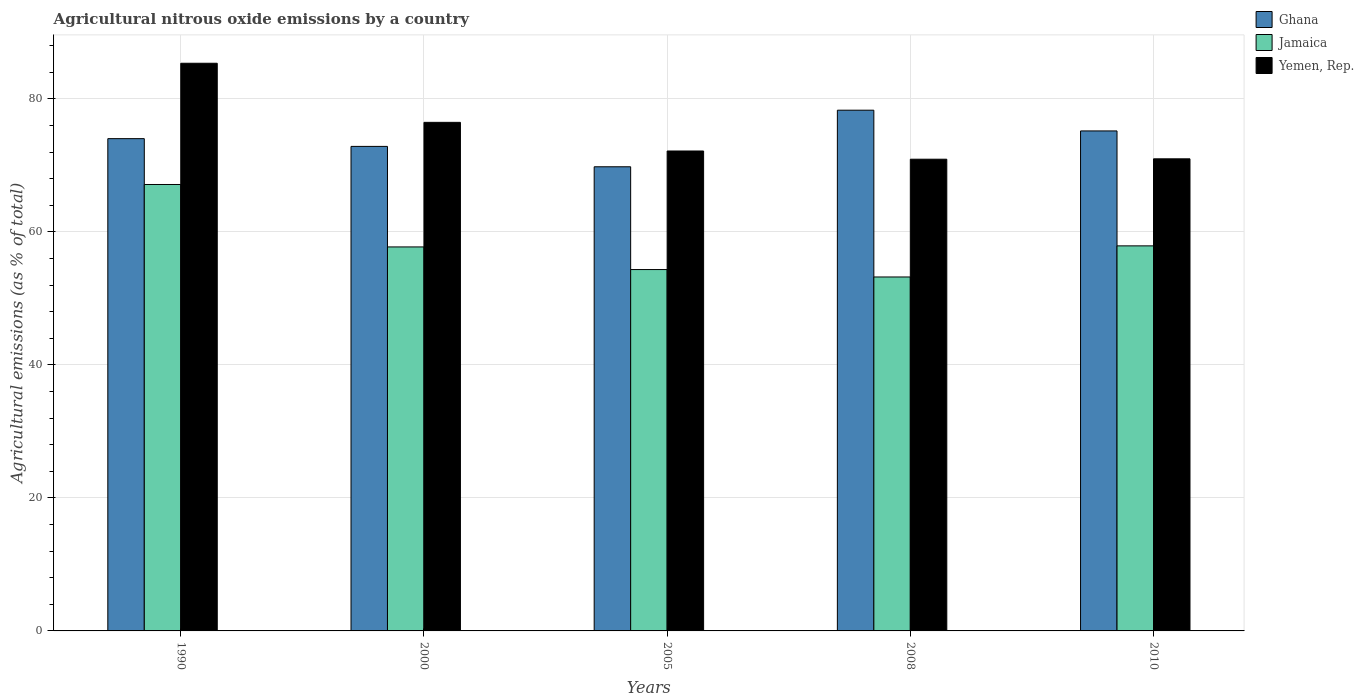How many different coloured bars are there?
Provide a short and direct response. 3. How many groups of bars are there?
Offer a very short reply. 5. Are the number of bars per tick equal to the number of legend labels?
Offer a terse response. Yes. Are the number of bars on each tick of the X-axis equal?
Ensure brevity in your answer.  Yes. How many bars are there on the 4th tick from the right?
Your answer should be very brief. 3. What is the amount of agricultural nitrous oxide emitted in Ghana in 2000?
Give a very brief answer. 72.86. Across all years, what is the maximum amount of agricultural nitrous oxide emitted in Jamaica?
Give a very brief answer. 67.13. Across all years, what is the minimum amount of agricultural nitrous oxide emitted in Jamaica?
Your response must be concise. 53.23. What is the total amount of agricultural nitrous oxide emitted in Yemen, Rep. in the graph?
Keep it short and to the point. 375.94. What is the difference between the amount of agricultural nitrous oxide emitted in Yemen, Rep. in 1990 and that in 2005?
Give a very brief answer. 13.19. What is the difference between the amount of agricultural nitrous oxide emitted in Ghana in 2005 and the amount of agricultural nitrous oxide emitted in Jamaica in 1990?
Your answer should be very brief. 2.67. What is the average amount of agricultural nitrous oxide emitted in Ghana per year?
Offer a very short reply. 74.04. In the year 2010, what is the difference between the amount of agricultural nitrous oxide emitted in Ghana and amount of agricultural nitrous oxide emitted in Jamaica?
Make the answer very short. 17.28. What is the ratio of the amount of agricultural nitrous oxide emitted in Jamaica in 1990 to that in 2008?
Offer a very short reply. 1.26. Is the difference between the amount of agricultural nitrous oxide emitted in Ghana in 2000 and 2010 greater than the difference between the amount of agricultural nitrous oxide emitted in Jamaica in 2000 and 2010?
Ensure brevity in your answer.  No. What is the difference between the highest and the second highest amount of agricultural nitrous oxide emitted in Ghana?
Your answer should be very brief. 3.12. What is the difference between the highest and the lowest amount of agricultural nitrous oxide emitted in Yemen, Rep.?
Offer a terse response. 14.43. What does the 2nd bar from the left in 1990 represents?
Offer a very short reply. Jamaica. How many bars are there?
Keep it short and to the point. 15. How many years are there in the graph?
Provide a succinct answer. 5. Does the graph contain any zero values?
Your answer should be compact. No. Does the graph contain grids?
Ensure brevity in your answer.  Yes. How are the legend labels stacked?
Provide a short and direct response. Vertical. What is the title of the graph?
Ensure brevity in your answer.  Agricultural nitrous oxide emissions by a country. Does "Northern Mariana Islands" appear as one of the legend labels in the graph?
Give a very brief answer. No. What is the label or title of the Y-axis?
Your response must be concise. Agricultural emissions (as % of total). What is the Agricultural emissions (as % of total) of Ghana in 1990?
Your answer should be compact. 74.03. What is the Agricultural emissions (as % of total) of Jamaica in 1990?
Provide a short and direct response. 67.13. What is the Agricultural emissions (as % of total) in Yemen, Rep. in 1990?
Make the answer very short. 85.36. What is the Agricultural emissions (as % of total) of Ghana in 2000?
Ensure brevity in your answer.  72.86. What is the Agricultural emissions (as % of total) in Jamaica in 2000?
Give a very brief answer. 57.75. What is the Agricultural emissions (as % of total) in Yemen, Rep. in 2000?
Your answer should be very brief. 76.48. What is the Agricultural emissions (as % of total) in Ghana in 2005?
Your answer should be compact. 69.8. What is the Agricultural emissions (as % of total) in Jamaica in 2005?
Your answer should be compact. 54.34. What is the Agricultural emissions (as % of total) in Yemen, Rep. in 2005?
Make the answer very short. 72.17. What is the Agricultural emissions (as % of total) of Ghana in 2008?
Provide a short and direct response. 78.31. What is the Agricultural emissions (as % of total) of Jamaica in 2008?
Offer a terse response. 53.23. What is the Agricultural emissions (as % of total) in Yemen, Rep. in 2008?
Give a very brief answer. 70.93. What is the Agricultural emissions (as % of total) in Ghana in 2010?
Provide a succinct answer. 75.19. What is the Agricultural emissions (as % of total) of Jamaica in 2010?
Make the answer very short. 57.9. What is the Agricultural emissions (as % of total) of Yemen, Rep. in 2010?
Provide a short and direct response. 70.99. Across all years, what is the maximum Agricultural emissions (as % of total) in Ghana?
Provide a succinct answer. 78.31. Across all years, what is the maximum Agricultural emissions (as % of total) in Jamaica?
Your answer should be very brief. 67.13. Across all years, what is the maximum Agricultural emissions (as % of total) in Yemen, Rep.?
Give a very brief answer. 85.36. Across all years, what is the minimum Agricultural emissions (as % of total) of Ghana?
Offer a very short reply. 69.8. Across all years, what is the minimum Agricultural emissions (as % of total) in Jamaica?
Your answer should be very brief. 53.23. Across all years, what is the minimum Agricultural emissions (as % of total) of Yemen, Rep.?
Provide a succinct answer. 70.93. What is the total Agricultural emissions (as % of total) of Ghana in the graph?
Give a very brief answer. 370.18. What is the total Agricultural emissions (as % of total) of Jamaica in the graph?
Make the answer very short. 290.35. What is the total Agricultural emissions (as % of total) in Yemen, Rep. in the graph?
Provide a short and direct response. 375.94. What is the difference between the Agricultural emissions (as % of total) in Ghana in 1990 and that in 2000?
Your answer should be compact. 1.17. What is the difference between the Agricultural emissions (as % of total) in Jamaica in 1990 and that in 2000?
Ensure brevity in your answer.  9.39. What is the difference between the Agricultural emissions (as % of total) of Yemen, Rep. in 1990 and that in 2000?
Provide a short and direct response. 8.89. What is the difference between the Agricultural emissions (as % of total) of Ghana in 1990 and that in 2005?
Make the answer very short. 4.23. What is the difference between the Agricultural emissions (as % of total) of Jamaica in 1990 and that in 2005?
Your answer should be very brief. 12.79. What is the difference between the Agricultural emissions (as % of total) in Yemen, Rep. in 1990 and that in 2005?
Your response must be concise. 13.19. What is the difference between the Agricultural emissions (as % of total) in Ghana in 1990 and that in 2008?
Keep it short and to the point. -4.28. What is the difference between the Agricultural emissions (as % of total) in Jamaica in 1990 and that in 2008?
Give a very brief answer. 13.91. What is the difference between the Agricultural emissions (as % of total) of Yemen, Rep. in 1990 and that in 2008?
Your response must be concise. 14.43. What is the difference between the Agricultural emissions (as % of total) in Ghana in 1990 and that in 2010?
Ensure brevity in your answer.  -1.16. What is the difference between the Agricultural emissions (as % of total) in Jamaica in 1990 and that in 2010?
Offer a very short reply. 9.23. What is the difference between the Agricultural emissions (as % of total) of Yemen, Rep. in 1990 and that in 2010?
Provide a succinct answer. 14.37. What is the difference between the Agricultural emissions (as % of total) in Ghana in 2000 and that in 2005?
Offer a very short reply. 3.06. What is the difference between the Agricultural emissions (as % of total) in Jamaica in 2000 and that in 2005?
Provide a succinct answer. 3.4. What is the difference between the Agricultural emissions (as % of total) in Yemen, Rep. in 2000 and that in 2005?
Offer a very short reply. 4.31. What is the difference between the Agricultural emissions (as % of total) in Ghana in 2000 and that in 2008?
Keep it short and to the point. -5.45. What is the difference between the Agricultural emissions (as % of total) in Jamaica in 2000 and that in 2008?
Make the answer very short. 4.52. What is the difference between the Agricultural emissions (as % of total) in Yemen, Rep. in 2000 and that in 2008?
Provide a short and direct response. 5.54. What is the difference between the Agricultural emissions (as % of total) in Ghana in 2000 and that in 2010?
Your answer should be compact. -2.33. What is the difference between the Agricultural emissions (as % of total) in Jamaica in 2000 and that in 2010?
Your answer should be compact. -0.16. What is the difference between the Agricultural emissions (as % of total) in Yemen, Rep. in 2000 and that in 2010?
Your answer should be very brief. 5.49. What is the difference between the Agricultural emissions (as % of total) in Ghana in 2005 and that in 2008?
Give a very brief answer. -8.51. What is the difference between the Agricultural emissions (as % of total) in Jamaica in 2005 and that in 2008?
Keep it short and to the point. 1.12. What is the difference between the Agricultural emissions (as % of total) in Yemen, Rep. in 2005 and that in 2008?
Ensure brevity in your answer.  1.24. What is the difference between the Agricultural emissions (as % of total) of Ghana in 2005 and that in 2010?
Your response must be concise. -5.39. What is the difference between the Agricultural emissions (as % of total) in Jamaica in 2005 and that in 2010?
Give a very brief answer. -3.56. What is the difference between the Agricultural emissions (as % of total) in Yemen, Rep. in 2005 and that in 2010?
Your response must be concise. 1.18. What is the difference between the Agricultural emissions (as % of total) of Ghana in 2008 and that in 2010?
Give a very brief answer. 3.12. What is the difference between the Agricultural emissions (as % of total) in Jamaica in 2008 and that in 2010?
Provide a succinct answer. -4.68. What is the difference between the Agricultural emissions (as % of total) in Yemen, Rep. in 2008 and that in 2010?
Your answer should be compact. -0.06. What is the difference between the Agricultural emissions (as % of total) of Ghana in 1990 and the Agricultural emissions (as % of total) of Jamaica in 2000?
Your answer should be compact. 16.28. What is the difference between the Agricultural emissions (as % of total) of Ghana in 1990 and the Agricultural emissions (as % of total) of Yemen, Rep. in 2000?
Provide a succinct answer. -2.45. What is the difference between the Agricultural emissions (as % of total) in Jamaica in 1990 and the Agricultural emissions (as % of total) in Yemen, Rep. in 2000?
Keep it short and to the point. -9.35. What is the difference between the Agricultural emissions (as % of total) in Ghana in 1990 and the Agricultural emissions (as % of total) in Jamaica in 2005?
Your answer should be compact. 19.68. What is the difference between the Agricultural emissions (as % of total) in Ghana in 1990 and the Agricultural emissions (as % of total) in Yemen, Rep. in 2005?
Provide a succinct answer. 1.86. What is the difference between the Agricultural emissions (as % of total) in Jamaica in 1990 and the Agricultural emissions (as % of total) in Yemen, Rep. in 2005?
Offer a very short reply. -5.04. What is the difference between the Agricultural emissions (as % of total) of Ghana in 1990 and the Agricultural emissions (as % of total) of Jamaica in 2008?
Offer a terse response. 20.8. What is the difference between the Agricultural emissions (as % of total) in Ghana in 1990 and the Agricultural emissions (as % of total) in Yemen, Rep. in 2008?
Keep it short and to the point. 3.09. What is the difference between the Agricultural emissions (as % of total) in Jamaica in 1990 and the Agricultural emissions (as % of total) in Yemen, Rep. in 2008?
Offer a terse response. -3.8. What is the difference between the Agricultural emissions (as % of total) of Ghana in 1990 and the Agricultural emissions (as % of total) of Jamaica in 2010?
Your response must be concise. 16.12. What is the difference between the Agricultural emissions (as % of total) in Ghana in 1990 and the Agricultural emissions (as % of total) in Yemen, Rep. in 2010?
Provide a succinct answer. 3.03. What is the difference between the Agricultural emissions (as % of total) in Jamaica in 1990 and the Agricultural emissions (as % of total) in Yemen, Rep. in 2010?
Offer a very short reply. -3.86. What is the difference between the Agricultural emissions (as % of total) of Ghana in 2000 and the Agricultural emissions (as % of total) of Jamaica in 2005?
Your answer should be compact. 18.52. What is the difference between the Agricultural emissions (as % of total) of Ghana in 2000 and the Agricultural emissions (as % of total) of Yemen, Rep. in 2005?
Provide a succinct answer. 0.69. What is the difference between the Agricultural emissions (as % of total) of Jamaica in 2000 and the Agricultural emissions (as % of total) of Yemen, Rep. in 2005?
Provide a short and direct response. -14.43. What is the difference between the Agricultural emissions (as % of total) in Ghana in 2000 and the Agricultural emissions (as % of total) in Jamaica in 2008?
Your response must be concise. 19.64. What is the difference between the Agricultural emissions (as % of total) in Ghana in 2000 and the Agricultural emissions (as % of total) in Yemen, Rep. in 2008?
Provide a succinct answer. 1.93. What is the difference between the Agricultural emissions (as % of total) of Jamaica in 2000 and the Agricultural emissions (as % of total) of Yemen, Rep. in 2008?
Give a very brief answer. -13.19. What is the difference between the Agricultural emissions (as % of total) in Ghana in 2000 and the Agricultural emissions (as % of total) in Jamaica in 2010?
Make the answer very short. 14.96. What is the difference between the Agricultural emissions (as % of total) of Ghana in 2000 and the Agricultural emissions (as % of total) of Yemen, Rep. in 2010?
Provide a succinct answer. 1.87. What is the difference between the Agricultural emissions (as % of total) in Jamaica in 2000 and the Agricultural emissions (as % of total) in Yemen, Rep. in 2010?
Offer a very short reply. -13.25. What is the difference between the Agricultural emissions (as % of total) in Ghana in 2005 and the Agricultural emissions (as % of total) in Jamaica in 2008?
Offer a terse response. 16.57. What is the difference between the Agricultural emissions (as % of total) of Ghana in 2005 and the Agricultural emissions (as % of total) of Yemen, Rep. in 2008?
Ensure brevity in your answer.  -1.14. What is the difference between the Agricultural emissions (as % of total) of Jamaica in 2005 and the Agricultural emissions (as % of total) of Yemen, Rep. in 2008?
Your answer should be very brief. -16.59. What is the difference between the Agricultural emissions (as % of total) of Ghana in 2005 and the Agricultural emissions (as % of total) of Jamaica in 2010?
Keep it short and to the point. 11.89. What is the difference between the Agricultural emissions (as % of total) of Ghana in 2005 and the Agricultural emissions (as % of total) of Yemen, Rep. in 2010?
Offer a very short reply. -1.2. What is the difference between the Agricultural emissions (as % of total) of Jamaica in 2005 and the Agricultural emissions (as % of total) of Yemen, Rep. in 2010?
Make the answer very short. -16.65. What is the difference between the Agricultural emissions (as % of total) in Ghana in 2008 and the Agricultural emissions (as % of total) in Jamaica in 2010?
Ensure brevity in your answer.  20.4. What is the difference between the Agricultural emissions (as % of total) of Ghana in 2008 and the Agricultural emissions (as % of total) of Yemen, Rep. in 2010?
Keep it short and to the point. 7.31. What is the difference between the Agricultural emissions (as % of total) in Jamaica in 2008 and the Agricultural emissions (as % of total) in Yemen, Rep. in 2010?
Make the answer very short. -17.77. What is the average Agricultural emissions (as % of total) of Ghana per year?
Offer a terse response. 74.04. What is the average Agricultural emissions (as % of total) in Jamaica per year?
Your answer should be very brief. 58.07. What is the average Agricultural emissions (as % of total) of Yemen, Rep. per year?
Give a very brief answer. 75.19. In the year 1990, what is the difference between the Agricultural emissions (as % of total) in Ghana and Agricultural emissions (as % of total) in Jamaica?
Keep it short and to the point. 6.89. In the year 1990, what is the difference between the Agricultural emissions (as % of total) in Ghana and Agricultural emissions (as % of total) in Yemen, Rep.?
Your answer should be compact. -11.34. In the year 1990, what is the difference between the Agricultural emissions (as % of total) of Jamaica and Agricultural emissions (as % of total) of Yemen, Rep.?
Provide a succinct answer. -18.23. In the year 2000, what is the difference between the Agricultural emissions (as % of total) of Ghana and Agricultural emissions (as % of total) of Jamaica?
Give a very brief answer. 15.12. In the year 2000, what is the difference between the Agricultural emissions (as % of total) of Ghana and Agricultural emissions (as % of total) of Yemen, Rep.?
Give a very brief answer. -3.62. In the year 2000, what is the difference between the Agricultural emissions (as % of total) of Jamaica and Agricultural emissions (as % of total) of Yemen, Rep.?
Offer a terse response. -18.73. In the year 2005, what is the difference between the Agricultural emissions (as % of total) in Ghana and Agricultural emissions (as % of total) in Jamaica?
Your answer should be very brief. 15.46. In the year 2005, what is the difference between the Agricultural emissions (as % of total) in Ghana and Agricultural emissions (as % of total) in Yemen, Rep.?
Make the answer very short. -2.37. In the year 2005, what is the difference between the Agricultural emissions (as % of total) of Jamaica and Agricultural emissions (as % of total) of Yemen, Rep.?
Your response must be concise. -17.83. In the year 2008, what is the difference between the Agricultural emissions (as % of total) of Ghana and Agricultural emissions (as % of total) of Jamaica?
Ensure brevity in your answer.  25.08. In the year 2008, what is the difference between the Agricultural emissions (as % of total) of Ghana and Agricultural emissions (as % of total) of Yemen, Rep.?
Ensure brevity in your answer.  7.37. In the year 2008, what is the difference between the Agricultural emissions (as % of total) in Jamaica and Agricultural emissions (as % of total) in Yemen, Rep.?
Your answer should be compact. -17.71. In the year 2010, what is the difference between the Agricultural emissions (as % of total) in Ghana and Agricultural emissions (as % of total) in Jamaica?
Your answer should be compact. 17.28. In the year 2010, what is the difference between the Agricultural emissions (as % of total) of Ghana and Agricultural emissions (as % of total) of Yemen, Rep.?
Your answer should be compact. 4.19. In the year 2010, what is the difference between the Agricultural emissions (as % of total) in Jamaica and Agricultural emissions (as % of total) in Yemen, Rep.?
Offer a very short reply. -13.09. What is the ratio of the Agricultural emissions (as % of total) of Jamaica in 1990 to that in 2000?
Your answer should be compact. 1.16. What is the ratio of the Agricultural emissions (as % of total) in Yemen, Rep. in 1990 to that in 2000?
Your answer should be compact. 1.12. What is the ratio of the Agricultural emissions (as % of total) in Ghana in 1990 to that in 2005?
Ensure brevity in your answer.  1.06. What is the ratio of the Agricultural emissions (as % of total) of Jamaica in 1990 to that in 2005?
Your answer should be very brief. 1.24. What is the ratio of the Agricultural emissions (as % of total) in Yemen, Rep. in 1990 to that in 2005?
Provide a short and direct response. 1.18. What is the ratio of the Agricultural emissions (as % of total) of Ghana in 1990 to that in 2008?
Make the answer very short. 0.95. What is the ratio of the Agricultural emissions (as % of total) in Jamaica in 1990 to that in 2008?
Keep it short and to the point. 1.26. What is the ratio of the Agricultural emissions (as % of total) in Yemen, Rep. in 1990 to that in 2008?
Your answer should be compact. 1.2. What is the ratio of the Agricultural emissions (as % of total) in Ghana in 1990 to that in 2010?
Keep it short and to the point. 0.98. What is the ratio of the Agricultural emissions (as % of total) in Jamaica in 1990 to that in 2010?
Offer a very short reply. 1.16. What is the ratio of the Agricultural emissions (as % of total) of Yemen, Rep. in 1990 to that in 2010?
Keep it short and to the point. 1.2. What is the ratio of the Agricultural emissions (as % of total) of Ghana in 2000 to that in 2005?
Keep it short and to the point. 1.04. What is the ratio of the Agricultural emissions (as % of total) of Jamaica in 2000 to that in 2005?
Make the answer very short. 1.06. What is the ratio of the Agricultural emissions (as % of total) of Yemen, Rep. in 2000 to that in 2005?
Offer a very short reply. 1.06. What is the ratio of the Agricultural emissions (as % of total) in Ghana in 2000 to that in 2008?
Provide a short and direct response. 0.93. What is the ratio of the Agricultural emissions (as % of total) in Jamaica in 2000 to that in 2008?
Your response must be concise. 1.08. What is the ratio of the Agricultural emissions (as % of total) of Yemen, Rep. in 2000 to that in 2008?
Make the answer very short. 1.08. What is the ratio of the Agricultural emissions (as % of total) of Ghana in 2000 to that in 2010?
Offer a very short reply. 0.97. What is the ratio of the Agricultural emissions (as % of total) in Jamaica in 2000 to that in 2010?
Your response must be concise. 1. What is the ratio of the Agricultural emissions (as % of total) of Yemen, Rep. in 2000 to that in 2010?
Ensure brevity in your answer.  1.08. What is the ratio of the Agricultural emissions (as % of total) of Ghana in 2005 to that in 2008?
Ensure brevity in your answer.  0.89. What is the ratio of the Agricultural emissions (as % of total) in Jamaica in 2005 to that in 2008?
Offer a very short reply. 1.02. What is the ratio of the Agricultural emissions (as % of total) in Yemen, Rep. in 2005 to that in 2008?
Provide a short and direct response. 1.02. What is the ratio of the Agricultural emissions (as % of total) of Ghana in 2005 to that in 2010?
Your response must be concise. 0.93. What is the ratio of the Agricultural emissions (as % of total) of Jamaica in 2005 to that in 2010?
Your answer should be very brief. 0.94. What is the ratio of the Agricultural emissions (as % of total) of Yemen, Rep. in 2005 to that in 2010?
Offer a very short reply. 1.02. What is the ratio of the Agricultural emissions (as % of total) of Ghana in 2008 to that in 2010?
Offer a very short reply. 1.04. What is the ratio of the Agricultural emissions (as % of total) in Jamaica in 2008 to that in 2010?
Give a very brief answer. 0.92. What is the ratio of the Agricultural emissions (as % of total) of Yemen, Rep. in 2008 to that in 2010?
Ensure brevity in your answer.  1. What is the difference between the highest and the second highest Agricultural emissions (as % of total) in Ghana?
Offer a very short reply. 3.12. What is the difference between the highest and the second highest Agricultural emissions (as % of total) of Jamaica?
Offer a very short reply. 9.23. What is the difference between the highest and the second highest Agricultural emissions (as % of total) in Yemen, Rep.?
Keep it short and to the point. 8.89. What is the difference between the highest and the lowest Agricultural emissions (as % of total) in Ghana?
Your answer should be compact. 8.51. What is the difference between the highest and the lowest Agricultural emissions (as % of total) of Jamaica?
Your answer should be very brief. 13.91. What is the difference between the highest and the lowest Agricultural emissions (as % of total) of Yemen, Rep.?
Your answer should be compact. 14.43. 